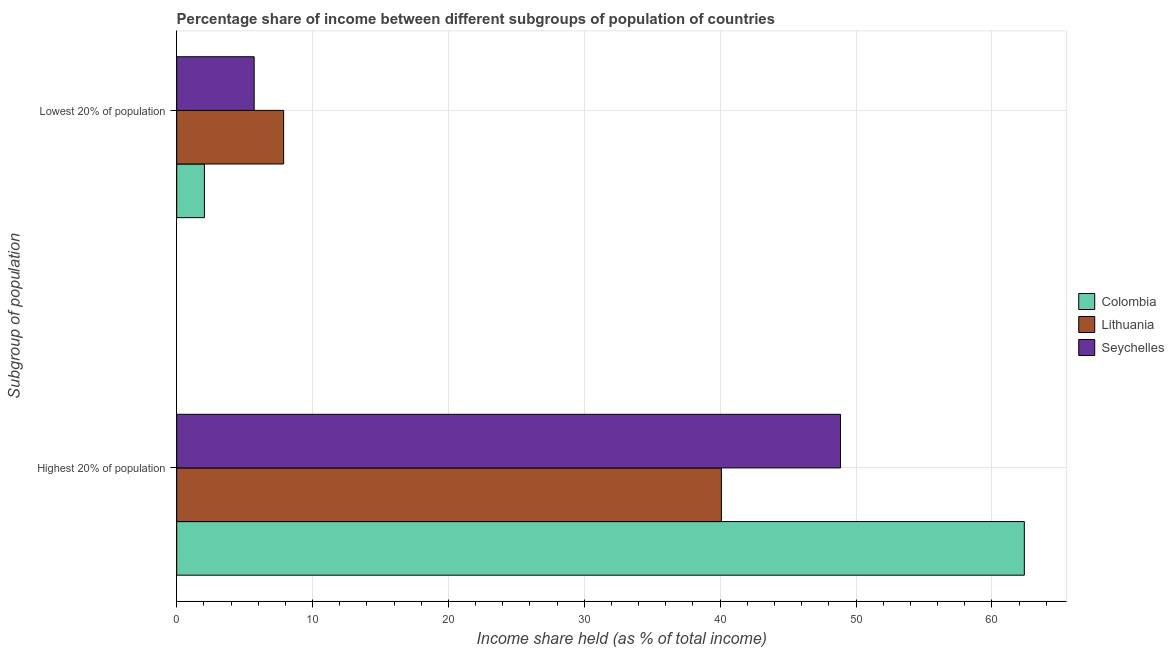How many different coloured bars are there?
Provide a succinct answer. 3. How many groups of bars are there?
Offer a terse response. 2. Are the number of bars on each tick of the Y-axis equal?
Give a very brief answer. Yes. How many bars are there on the 2nd tick from the top?
Your answer should be compact. 3. How many bars are there on the 2nd tick from the bottom?
Your response must be concise. 3. What is the label of the 1st group of bars from the top?
Your response must be concise. Lowest 20% of population. What is the income share held by highest 20% of the population in Colombia?
Make the answer very short. 62.39. Across all countries, what is the maximum income share held by lowest 20% of the population?
Provide a short and direct response. 7.87. Across all countries, what is the minimum income share held by lowest 20% of the population?
Keep it short and to the point. 2.04. In which country was the income share held by highest 20% of the population maximum?
Offer a terse response. Colombia. In which country was the income share held by highest 20% of the population minimum?
Your response must be concise. Lithuania. What is the total income share held by lowest 20% of the population in the graph?
Your response must be concise. 15.61. What is the difference between the income share held by highest 20% of the population in Lithuania and that in Seychelles?
Your answer should be very brief. -8.77. What is the difference between the income share held by lowest 20% of the population in Lithuania and the income share held by highest 20% of the population in Colombia?
Provide a succinct answer. -54.52. What is the average income share held by lowest 20% of the population per country?
Give a very brief answer. 5.2. What is the difference between the income share held by highest 20% of the population and income share held by lowest 20% of the population in Lithuania?
Give a very brief answer. 32.22. In how many countries, is the income share held by lowest 20% of the population greater than 12 %?
Offer a very short reply. 0. What is the ratio of the income share held by lowest 20% of the population in Colombia to that in Lithuania?
Offer a very short reply. 0.26. Is the income share held by highest 20% of the population in Colombia less than that in Lithuania?
Keep it short and to the point. No. What does the 1st bar from the top in Highest 20% of population represents?
Your answer should be very brief. Seychelles. Are all the bars in the graph horizontal?
Provide a short and direct response. Yes. How many countries are there in the graph?
Offer a very short reply. 3. What is the difference between two consecutive major ticks on the X-axis?
Keep it short and to the point. 10. Are the values on the major ticks of X-axis written in scientific E-notation?
Provide a short and direct response. No. Does the graph contain grids?
Give a very brief answer. Yes. How many legend labels are there?
Your answer should be compact. 3. What is the title of the graph?
Your response must be concise. Percentage share of income between different subgroups of population of countries. What is the label or title of the X-axis?
Make the answer very short. Income share held (as % of total income). What is the label or title of the Y-axis?
Offer a terse response. Subgroup of population. What is the Income share held (as % of total income) of Colombia in Highest 20% of population?
Your response must be concise. 62.39. What is the Income share held (as % of total income) in Lithuania in Highest 20% of population?
Give a very brief answer. 40.09. What is the Income share held (as % of total income) of Seychelles in Highest 20% of population?
Your answer should be compact. 48.86. What is the Income share held (as % of total income) of Colombia in Lowest 20% of population?
Your response must be concise. 2.04. What is the Income share held (as % of total income) of Lithuania in Lowest 20% of population?
Your answer should be very brief. 7.87. What is the Income share held (as % of total income) of Seychelles in Lowest 20% of population?
Offer a very short reply. 5.7. Across all Subgroup of population, what is the maximum Income share held (as % of total income) in Colombia?
Keep it short and to the point. 62.39. Across all Subgroup of population, what is the maximum Income share held (as % of total income) in Lithuania?
Provide a succinct answer. 40.09. Across all Subgroup of population, what is the maximum Income share held (as % of total income) of Seychelles?
Offer a terse response. 48.86. Across all Subgroup of population, what is the minimum Income share held (as % of total income) in Colombia?
Your answer should be very brief. 2.04. Across all Subgroup of population, what is the minimum Income share held (as % of total income) in Lithuania?
Offer a terse response. 7.87. Across all Subgroup of population, what is the minimum Income share held (as % of total income) in Seychelles?
Provide a succinct answer. 5.7. What is the total Income share held (as % of total income) of Colombia in the graph?
Provide a succinct answer. 64.43. What is the total Income share held (as % of total income) in Lithuania in the graph?
Make the answer very short. 47.96. What is the total Income share held (as % of total income) of Seychelles in the graph?
Make the answer very short. 54.56. What is the difference between the Income share held (as % of total income) of Colombia in Highest 20% of population and that in Lowest 20% of population?
Make the answer very short. 60.35. What is the difference between the Income share held (as % of total income) in Lithuania in Highest 20% of population and that in Lowest 20% of population?
Keep it short and to the point. 32.22. What is the difference between the Income share held (as % of total income) of Seychelles in Highest 20% of population and that in Lowest 20% of population?
Ensure brevity in your answer.  43.16. What is the difference between the Income share held (as % of total income) of Colombia in Highest 20% of population and the Income share held (as % of total income) of Lithuania in Lowest 20% of population?
Your answer should be very brief. 54.52. What is the difference between the Income share held (as % of total income) in Colombia in Highest 20% of population and the Income share held (as % of total income) in Seychelles in Lowest 20% of population?
Ensure brevity in your answer.  56.69. What is the difference between the Income share held (as % of total income) of Lithuania in Highest 20% of population and the Income share held (as % of total income) of Seychelles in Lowest 20% of population?
Keep it short and to the point. 34.39. What is the average Income share held (as % of total income) in Colombia per Subgroup of population?
Your answer should be very brief. 32.22. What is the average Income share held (as % of total income) of Lithuania per Subgroup of population?
Keep it short and to the point. 23.98. What is the average Income share held (as % of total income) in Seychelles per Subgroup of population?
Keep it short and to the point. 27.28. What is the difference between the Income share held (as % of total income) in Colombia and Income share held (as % of total income) in Lithuania in Highest 20% of population?
Your response must be concise. 22.3. What is the difference between the Income share held (as % of total income) of Colombia and Income share held (as % of total income) of Seychelles in Highest 20% of population?
Give a very brief answer. 13.53. What is the difference between the Income share held (as % of total income) in Lithuania and Income share held (as % of total income) in Seychelles in Highest 20% of population?
Offer a terse response. -8.77. What is the difference between the Income share held (as % of total income) of Colombia and Income share held (as % of total income) of Lithuania in Lowest 20% of population?
Ensure brevity in your answer.  -5.83. What is the difference between the Income share held (as % of total income) of Colombia and Income share held (as % of total income) of Seychelles in Lowest 20% of population?
Provide a succinct answer. -3.66. What is the difference between the Income share held (as % of total income) in Lithuania and Income share held (as % of total income) in Seychelles in Lowest 20% of population?
Your answer should be very brief. 2.17. What is the ratio of the Income share held (as % of total income) of Colombia in Highest 20% of population to that in Lowest 20% of population?
Keep it short and to the point. 30.58. What is the ratio of the Income share held (as % of total income) of Lithuania in Highest 20% of population to that in Lowest 20% of population?
Your answer should be compact. 5.09. What is the ratio of the Income share held (as % of total income) of Seychelles in Highest 20% of population to that in Lowest 20% of population?
Provide a short and direct response. 8.57. What is the difference between the highest and the second highest Income share held (as % of total income) of Colombia?
Make the answer very short. 60.35. What is the difference between the highest and the second highest Income share held (as % of total income) of Lithuania?
Provide a short and direct response. 32.22. What is the difference between the highest and the second highest Income share held (as % of total income) of Seychelles?
Your response must be concise. 43.16. What is the difference between the highest and the lowest Income share held (as % of total income) of Colombia?
Your response must be concise. 60.35. What is the difference between the highest and the lowest Income share held (as % of total income) of Lithuania?
Offer a terse response. 32.22. What is the difference between the highest and the lowest Income share held (as % of total income) in Seychelles?
Keep it short and to the point. 43.16. 